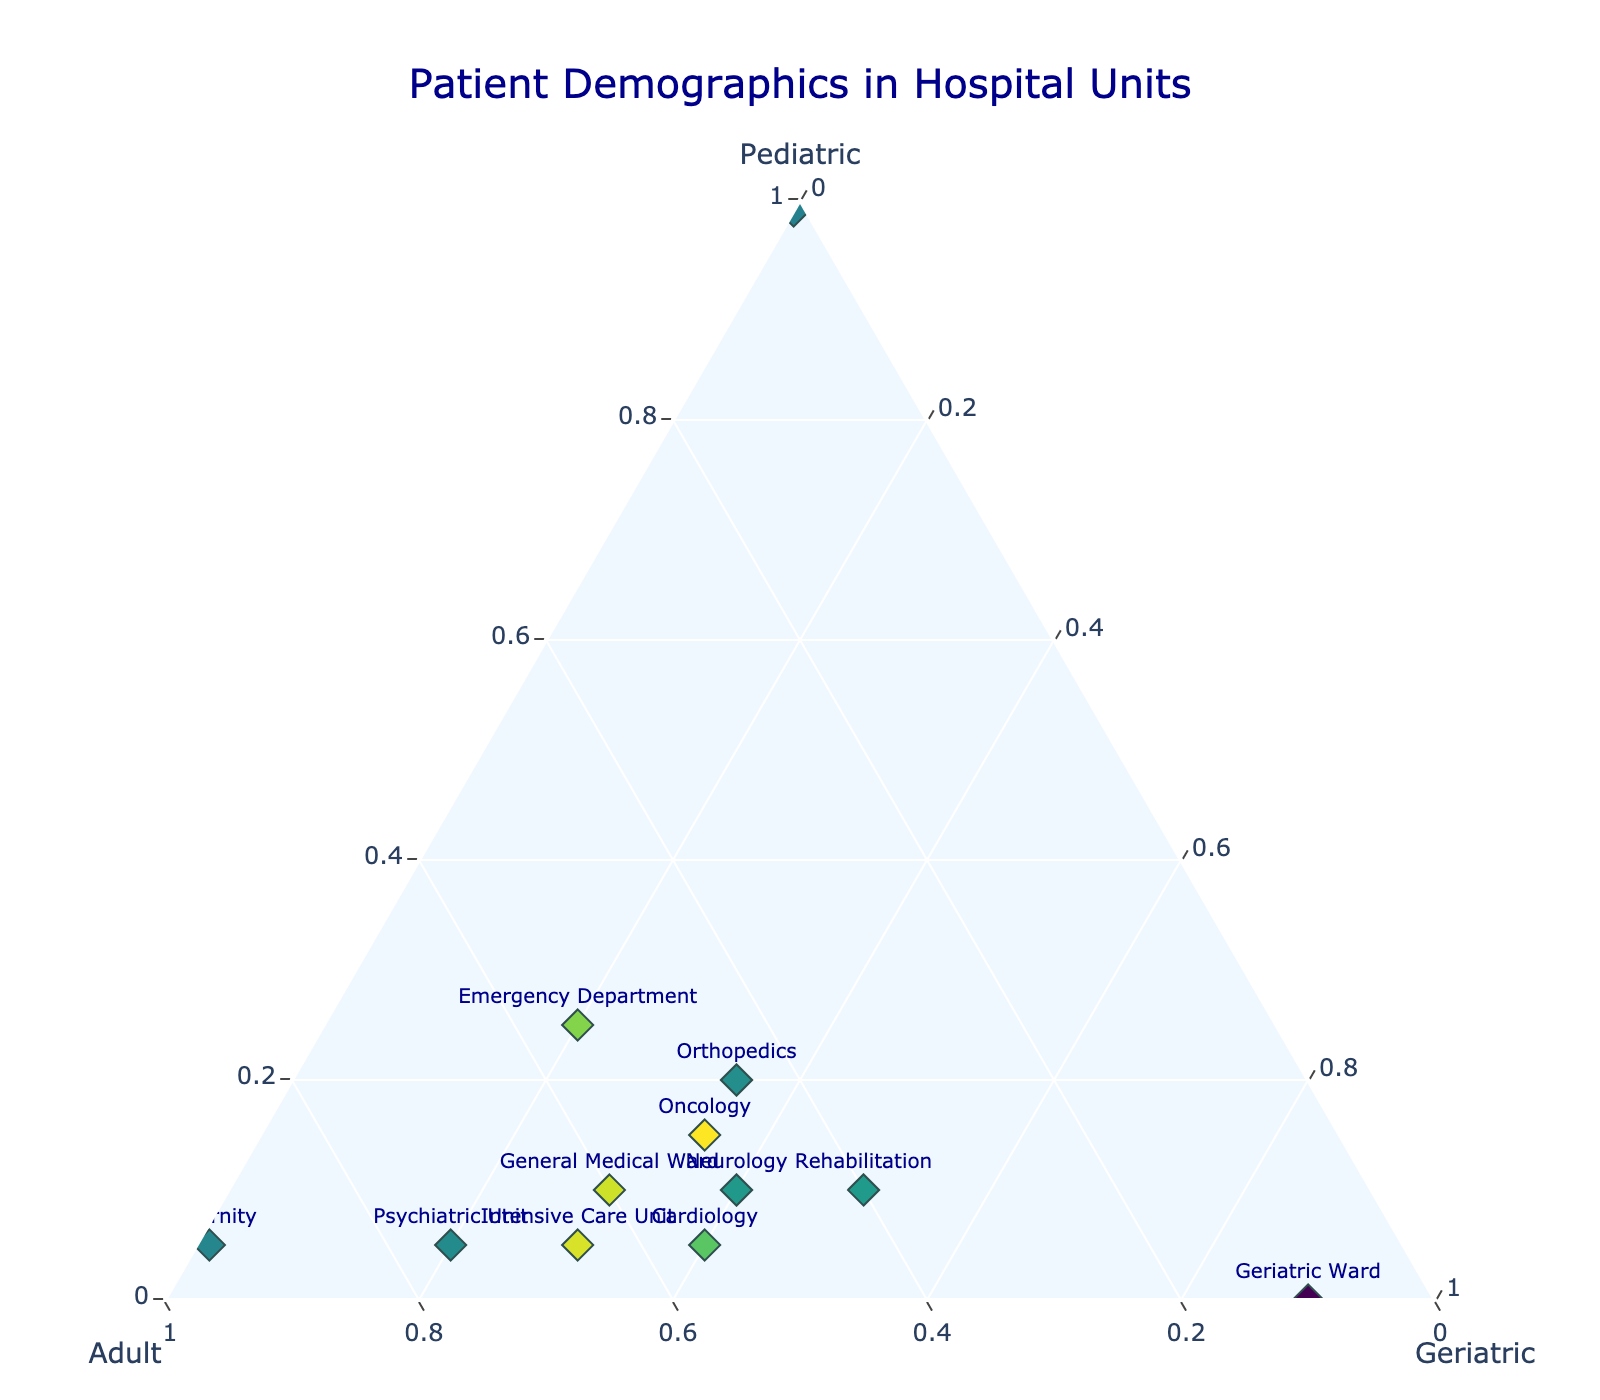what is the title of the figure? The title of the figure is located at the top of the plot, and it summarizes what the figure is about.
Answer: Patient Demographics in Hospital Units Which hospital unit has the highest percentage of pediatric patients? Identify the unit with the largest value on the axis labeled 'Pediatric.' The Neonatal ICU has the highest percentage of pediatric patients at 99%.
Answer: Neonatal ICU How many hospital units have a geriatric patient percentage higher than 50%? Look for data points where the 'Geriatric' percentage exceeds 50%. The Geriatric Ward and Rehabilitation unit have geriatric percentages higher than 50%.
Answer: Two Which units have an equal percentage of adult and geriatric patients? Compare the 'Adult' and 'Geriatric' percentages for each unit. The Intensive Care Unit has 65% adults and 30% geriatric, and the Neurology unit has 50% adults and 40% geriatric. None have equal percentages.
Answer: None Which unit has the lowest percentage of geriatric patients? Look for the unit with the smallest value on the 'Geriatric' axis. The Neonatal ICU has 0% geriatric patients.
Answer: Neonatal ICU If we combine the Pediatric and Geriatric percentages, which unit has the highest combined percentage? Add the 'Pediatric' and 'Geriatric' percentages for each unit. The Geriatric Ward has 90% geriatric and 0% pediatric, totaling 90%.
Answer: Geriatric Ward Is there any unit where the percentage of adult patients is the same as the sum of pediatric and geriatric patients? For each unit, compare the adult percentage with the sum of pediatric and geriatric percentages. In the Neurology unit, 50% adults = 10% pediatric + 40% geriatric.
Answer: Neurology What is the average pediatric percentage across all units? Sum the pediatric percentages across all units and divide by the number of units. (25+10+5+15+20+5+10+5+99+0+5+10) / 12 = 17.92%
Answer: 17.92% 